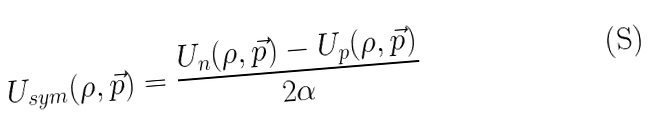Convert formula to latex. <formula><loc_0><loc_0><loc_500><loc_500>U _ { s y m } ( \rho , \vec { p } ) = \frac { U _ { n } ( \rho , \vec { p } ) - U _ { p } ( \rho , \vec { p } ) } { 2 \alpha }</formula> 